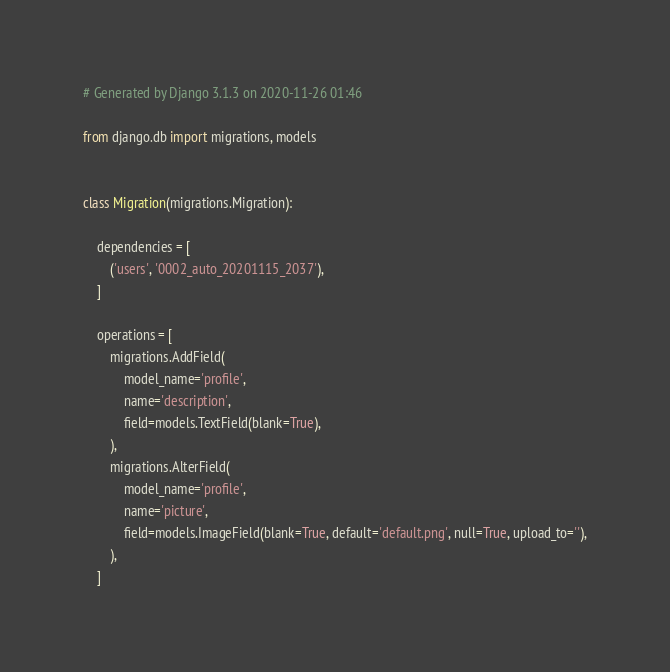<code> <loc_0><loc_0><loc_500><loc_500><_Python_># Generated by Django 3.1.3 on 2020-11-26 01:46

from django.db import migrations, models


class Migration(migrations.Migration):

    dependencies = [
        ('users', '0002_auto_20201115_2037'),
    ]

    operations = [
        migrations.AddField(
            model_name='profile',
            name='description',
            field=models.TextField(blank=True),
        ),
        migrations.AlterField(
            model_name='profile',
            name='picture',
            field=models.ImageField(blank=True, default='default.png', null=True, upload_to=''),
        ),
    ]
</code> 